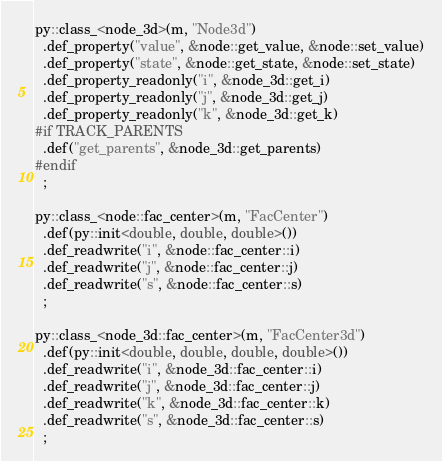<code> <loc_0><loc_0><loc_500><loc_500><_C++_>
py::class_<node_3d>(m, "Node3d")
  .def_property("value", &node::get_value, &node::set_value)
  .def_property("state", &node::get_state, &node::set_state)
  .def_property_readonly("i", &node_3d::get_i)
  .def_property_readonly("j", &node_3d::get_j)
  .def_property_readonly("k", &node_3d::get_k)
#if TRACK_PARENTS
  .def("get_parents", &node_3d::get_parents)
#endif
  ;

py::class_<node::fac_center>(m, "FacCenter")
  .def(py::init<double, double, double>())
  .def_readwrite("i", &node::fac_center::i)
  .def_readwrite("j", &node::fac_center::j)
  .def_readwrite("s", &node::fac_center::s)
  ;

py::class_<node_3d::fac_center>(m, "FacCenter3d")
  .def(py::init<double, double, double, double>())
  .def_readwrite("i", &node_3d::fac_center::i)
  .def_readwrite("j", &node_3d::fac_center::j)
  .def_readwrite("k", &node_3d::fac_center::k)
  .def_readwrite("s", &node_3d::fac_center::s)
  ;
</code> 